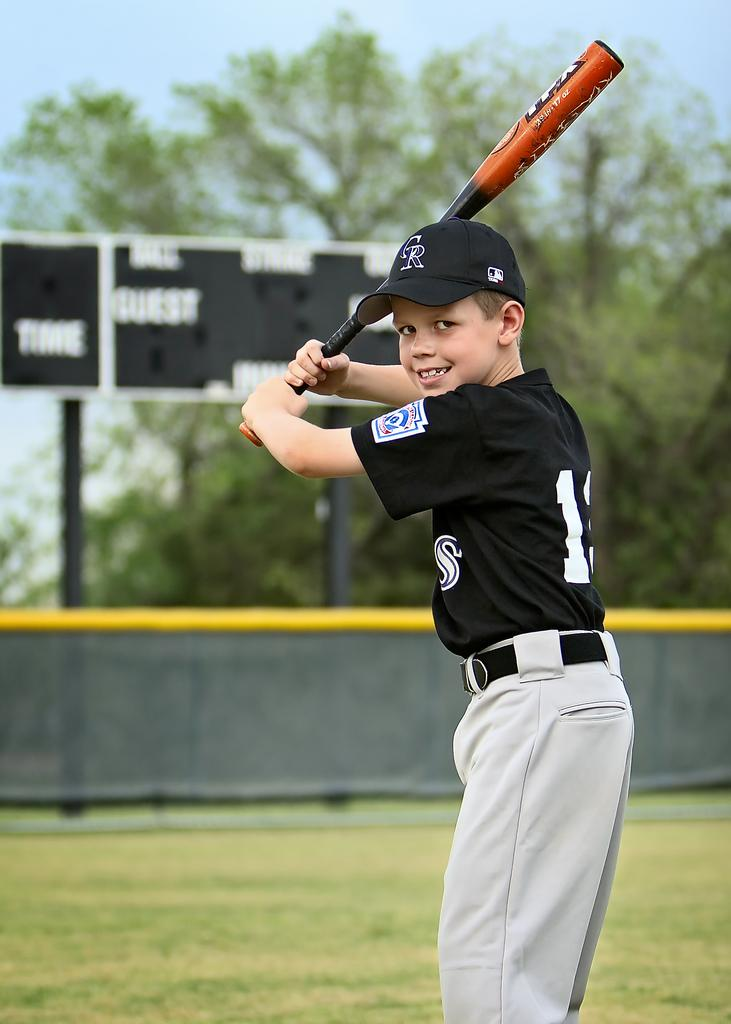<image>
Relay a brief, clear account of the picture shown. Boy holding bat and smiling in a CR logo hat and black and white uniform 